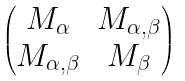Convert formula to latex. <formula><loc_0><loc_0><loc_500><loc_500>\begin{pmatrix} M _ { \alpha } & M _ { \alpha , \beta } \\ M _ { \alpha , \beta } & M _ { \beta } \end{pmatrix}</formula> 